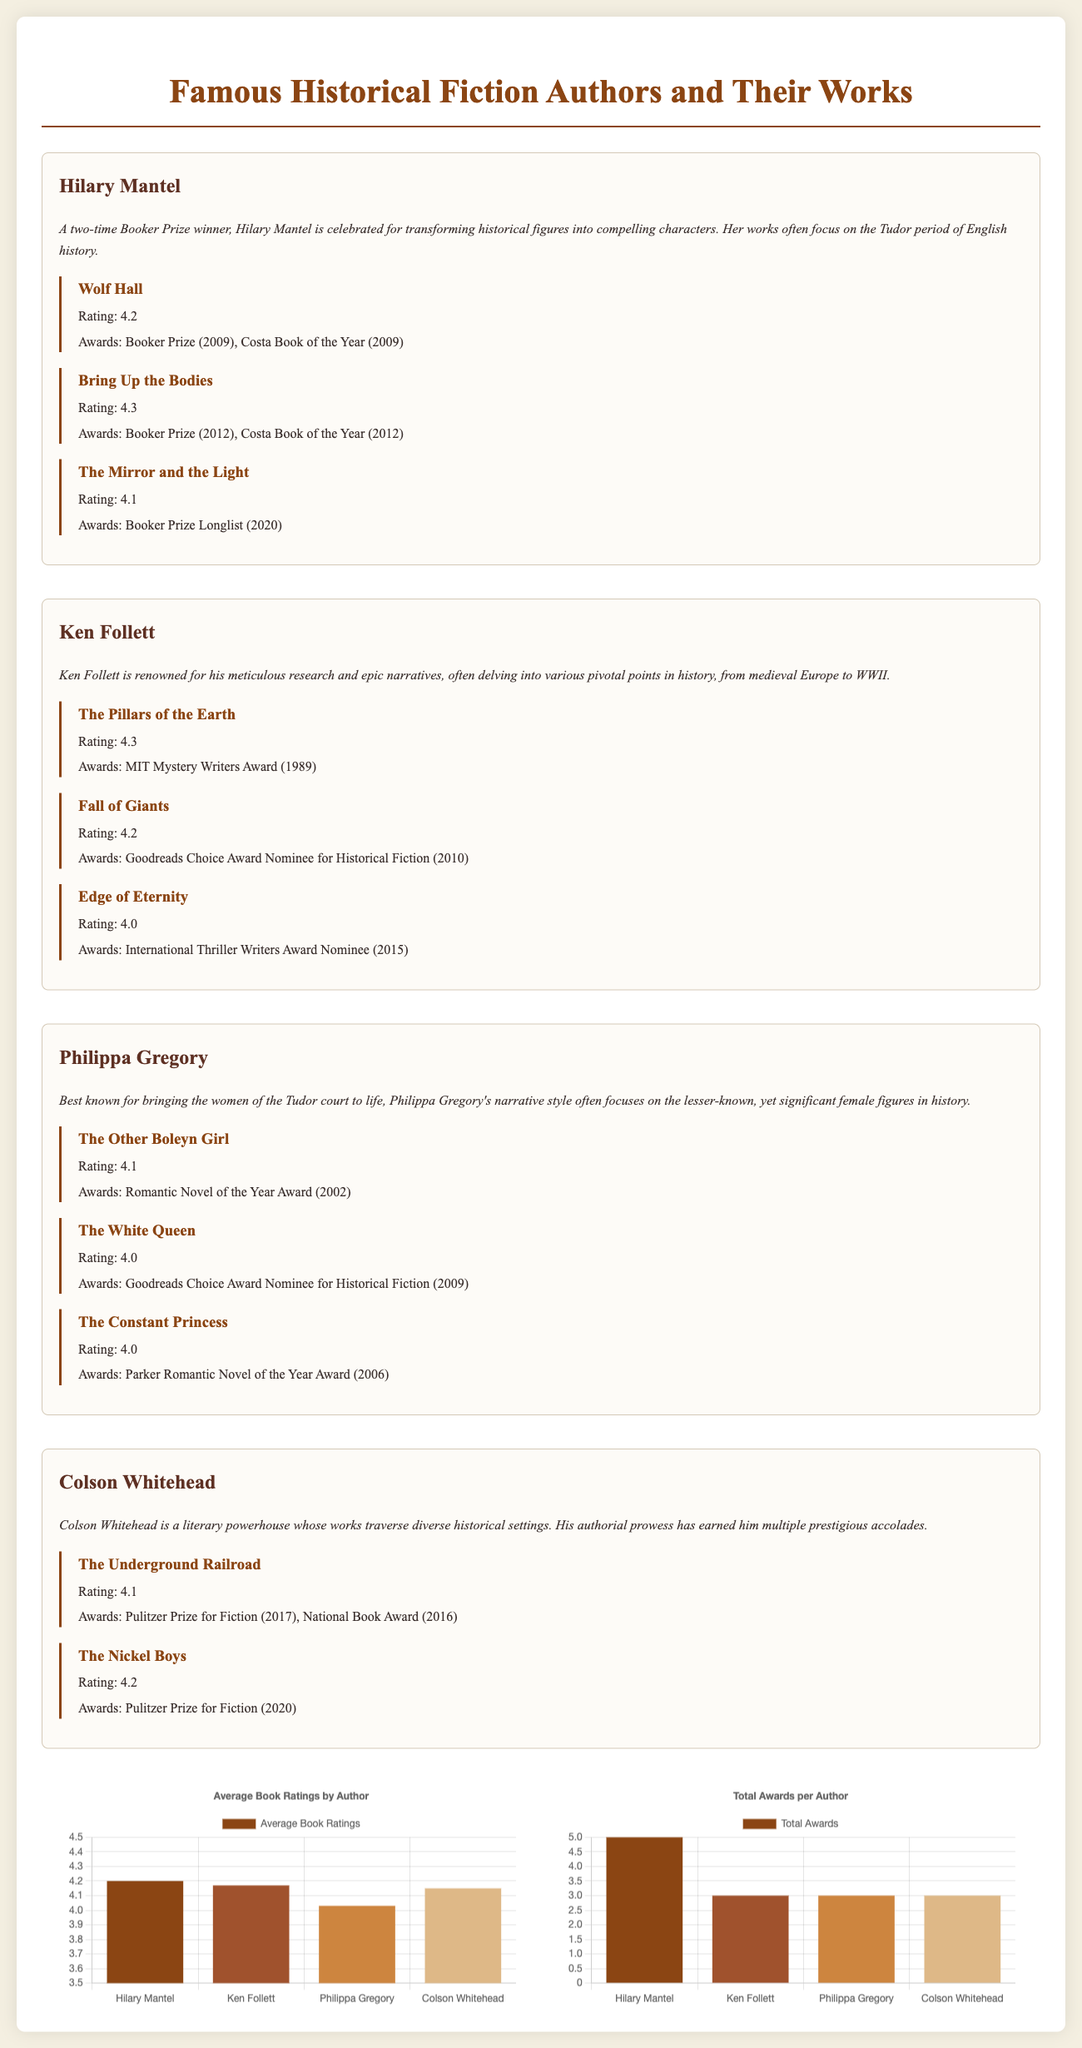What is the average book rating for Hilary Mantel? The average book rating for Hilary Mantel can be found under her profile, which lists her book ratings.
Answer: 4.2 How many awards has Ken Follett received? The total number of awards for Ken Follett is shown in the awards chart, which lists the total for each author.
Answer: 3 Which author has the highest average book rating? The average book ratings for all authors are compared in the rating chart, showing which author has the highest rating.
Answer: Ken Follett What is the rating of "The Other Boleyn Girl"? The rating of "The Other Boleyn Girl" is specified in Philippa Gregory's book list under her author profile.
Answer: 4.1 Who is the author of "The Underground Railroad"? The document mentions the author of "The Underground Railroad" in Colson Whitehead's profile, which provides the title and ratings.
Answer: Colson Whitehead Which book by Hilary Mantel won the Booker Prize? The books listed under Hilary Mantel's profile specify that "Wolf Hall" and "Bring Up the Bodies" won the Booker Prize.
Answer: Wolf Hall, Bring Up the Bodies What is the total number of awards received by Hilary Mantel? The number of awards for Hilary Mantel can be determined by checking the awards column next to her name in the awards chart.
Answer: 5 Which author has written the most critically acclaimed works in this infographic? The infographic allows us to compare the ratings and awards across authors, determining the author with the most acclaim.
Answer: Hilary Mantel What is the rating of Ken Follett's book "Edge of Eternity"? The rating for "Edge of Eternity" can be found in Ken Follett's section, where his books and their ratings are listed.
Answer: 4.0 